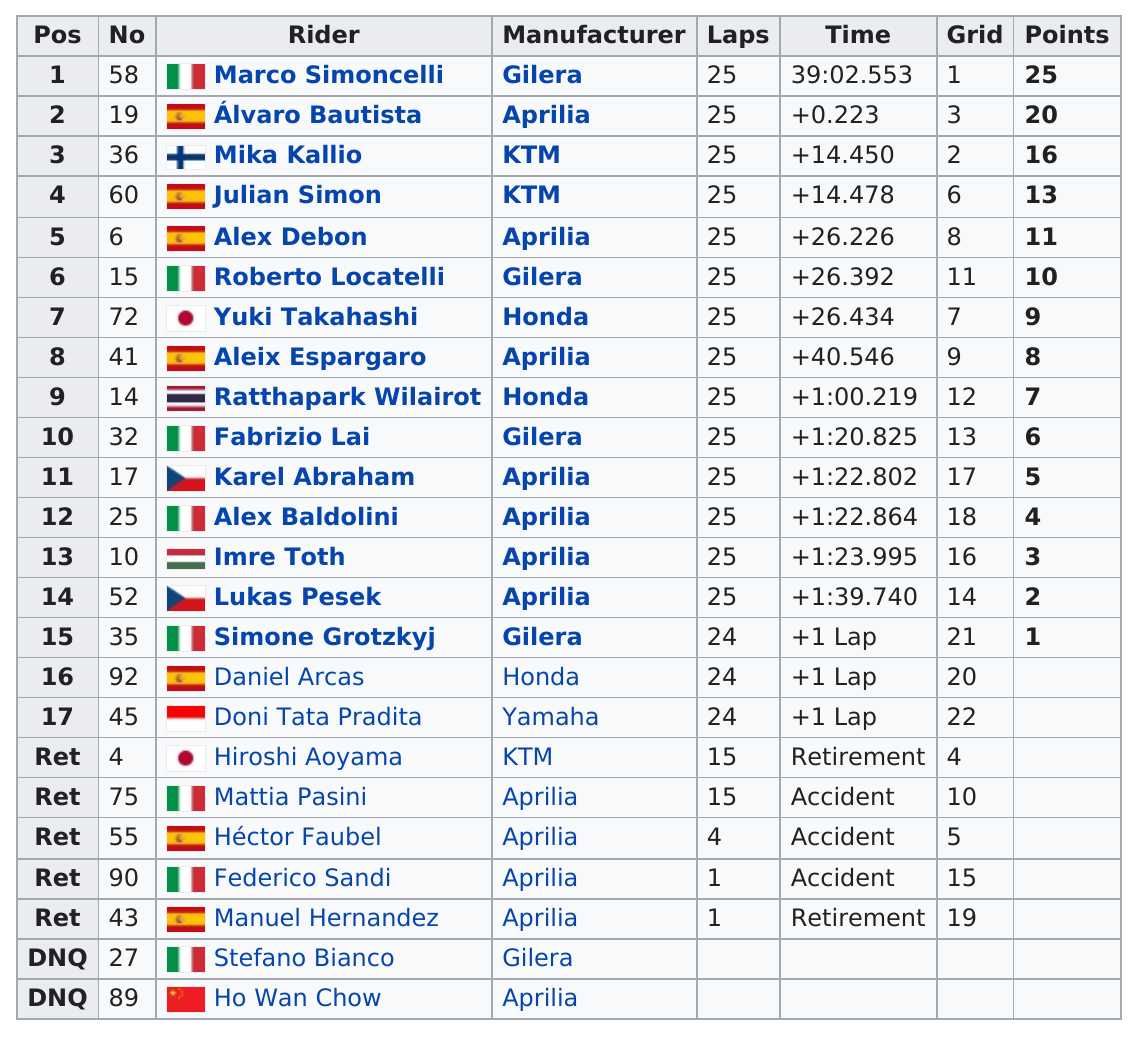Draw attention to some important aspects in this diagram. Mika Kallio precedes Julian Simon in the rider lineup. The country with the most riders was Italy. The manufacturer of Marco Simoncelli, the motorcycle rider, is Gilera. Honda is the manufacturer of 3 riders. Marco Simoncelli had the most points out of all the people. 